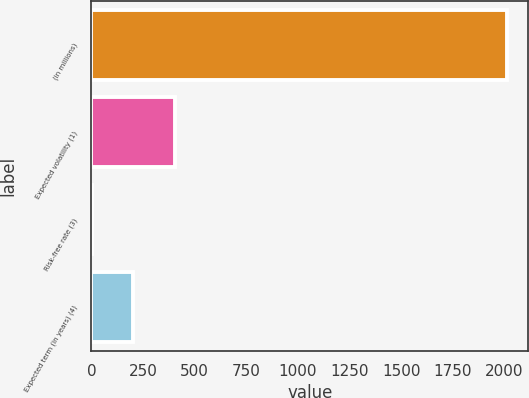Convert chart to OTSL. <chart><loc_0><loc_0><loc_500><loc_500><bar_chart><fcel>(in millions)<fcel>Expected volatility (1)<fcel>Risk-free rate (3)<fcel>Expected term (in years) (4)<nl><fcel>2014<fcel>404.29<fcel>1.85<fcel>203.07<nl></chart> 